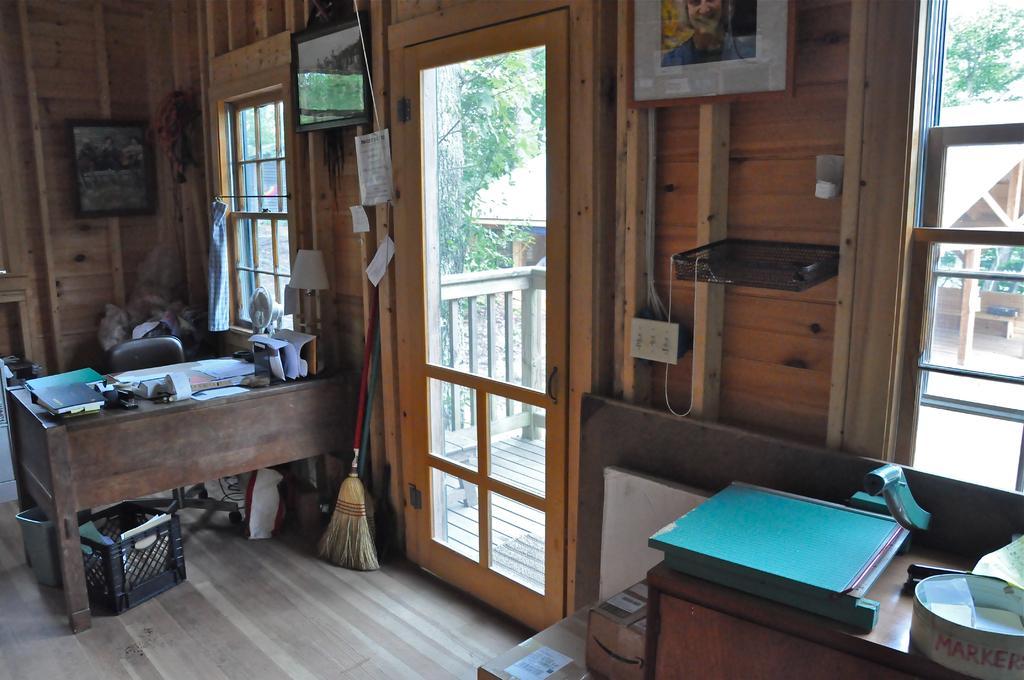Could you give a brief overview of what you see in this image? In this picture there is book, machine, paper on the desk. There are two boxes on the floor. A book , file , paper and other objects on the table are seen. There is a broom ,bad and a back box. Few paper are kept in a black box. A grey bin is seen under the table. A frame is present on the wooden wall. There is a black shelf , tree and a house is seen in the background. There are few papers attached to the wooden the wooden wall. A lamp is seen on the table. 